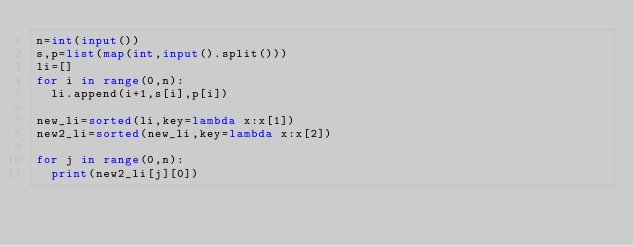Convert code to text. <code><loc_0><loc_0><loc_500><loc_500><_Python_>n=int(input())
s,p=list(map(int,input().split()))
li=[]
for i in range(0,n):
  li.append(i+1,s[i],p[i])

new_li=sorted(li,key=lambda x:x[1])
new2_li=sorted(new_li,key=lambda x:x[2])

for j in range(0,n):
  print(new2_li[j][0])</code> 